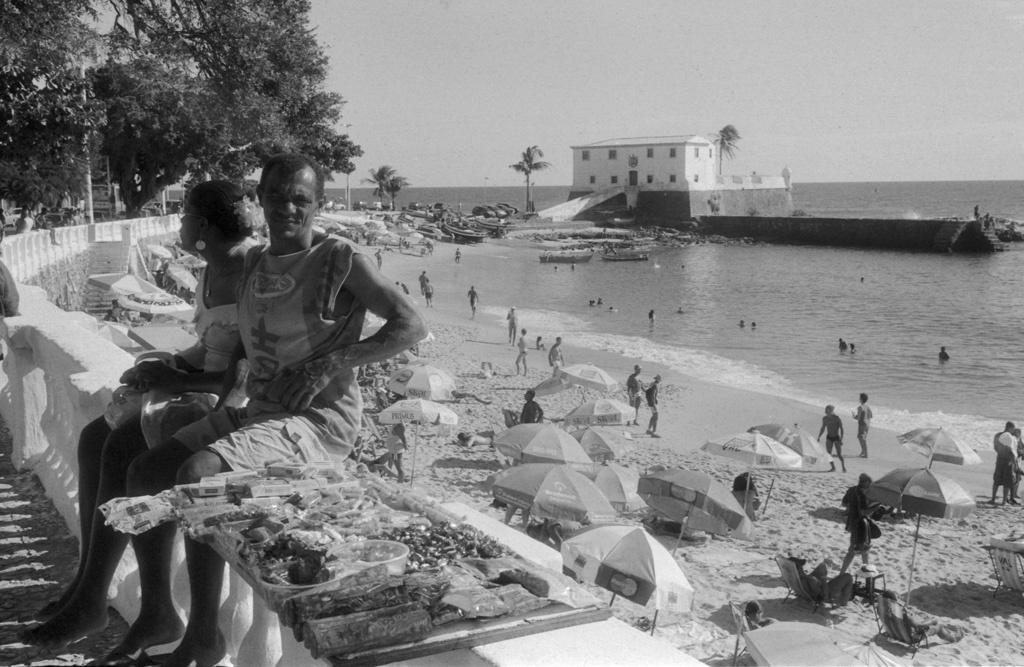Could you give a brief overview of what you see in this image? This picture is a black and white image. In this image we can see the sea, one building with wall, one white wall on the left side of the image, some boats on the water, some boats on the land, some umbrellas with poles, some folding chairs, some objects on the ground, some poles, some trees, at the top there is the sky, some people are sitting, some people are standing, some people are walking, some people on the wall near the house, some people in the water, some objects on the boats, few people holding objects, one board on the left side of the image and one big plate full of food on the wall on the left side of the image. 